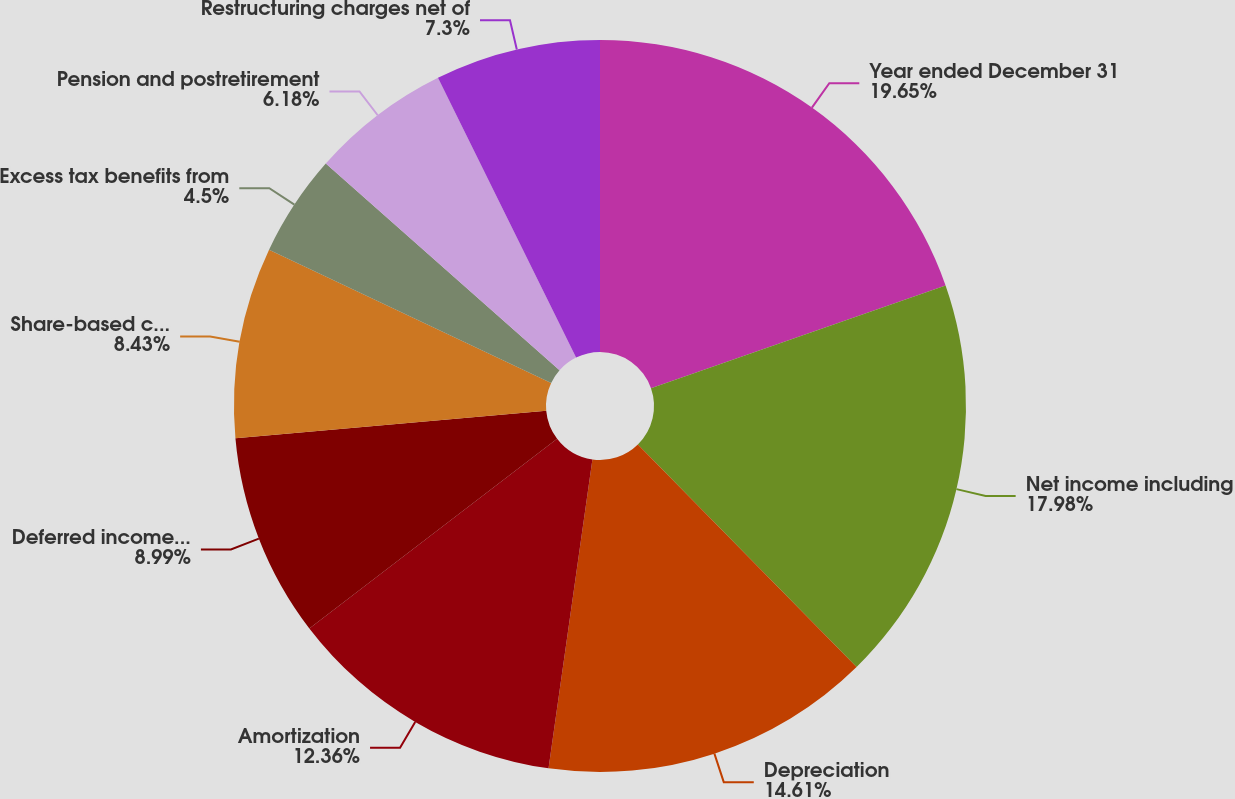Convert chart. <chart><loc_0><loc_0><loc_500><loc_500><pie_chart><fcel>Year ended December 31<fcel>Net income including<fcel>Depreciation<fcel>Amortization<fcel>Deferred income taxes<fcel>Share-based compensation<fcel>Excess tax benefits from<fcel>Pension and postretirement<fcel>Restructuring charges net of<nl><fcel>19.66%<fcel>17.98%<fcel>14.61%<fcel>12.36%<fcel>8.99%<fcel>8.43%<fcel>4.5%<fcel>6.18%<fcel>7.3%<nl></chart> 